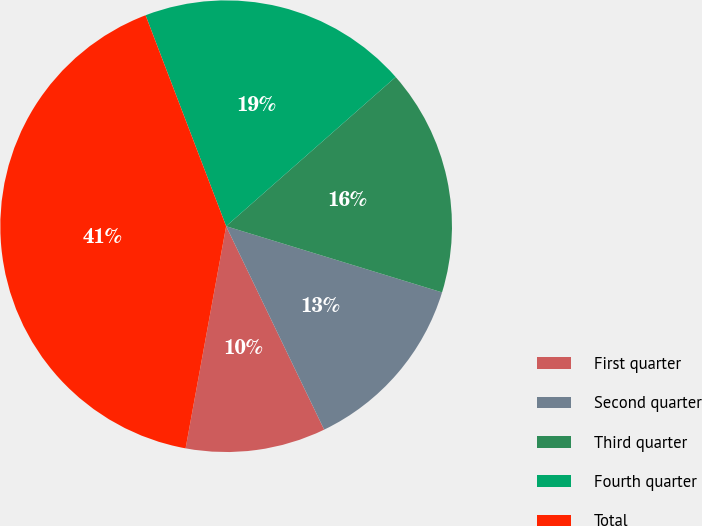Convert chart to OTSL. <chart><loc_0><loc_0><loc_500><loc_500><pie_chart><fcel>First quarter<fcel>Second quarter<fcel>Third quarter<fcel>Fourth quarter<fcel>Total<nl><fcel>10.02%<fcel>13.12%<fcel>16.22%<fcel>19.32%<fcel>41.32%<nl></chart> 